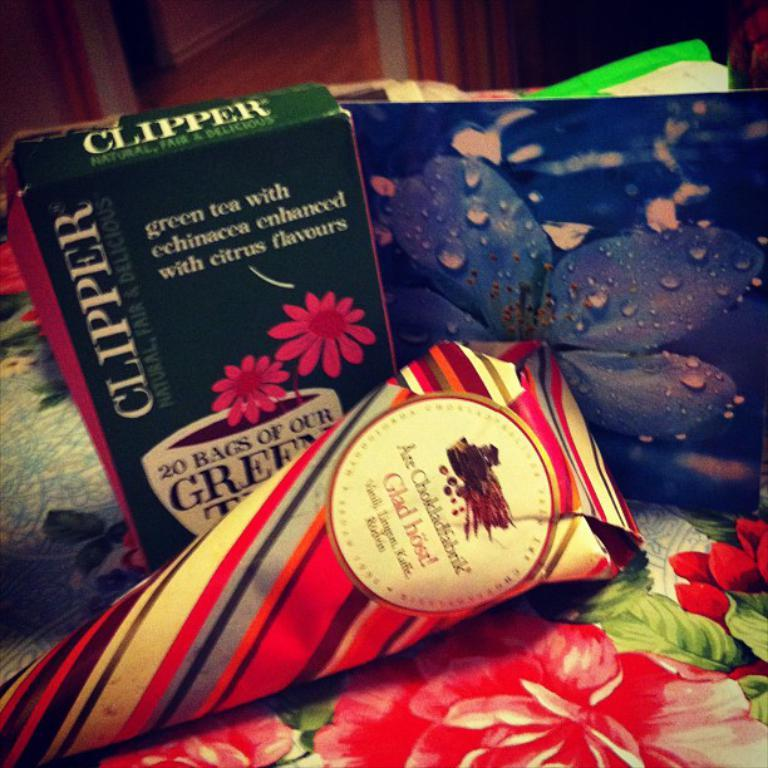<image>
Describe the image concisely. A green box holds 20 bags of green tea. 